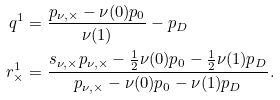<formula> <loc_0><loc_0><loc_500><loc_500>q ^ { 1 } & = \frac { p _ { \nu , \times } - \nu ( 0 ) p _ { 0 } } { \nu ( 1 ) } - p _ { D } \\ r ^ { 1 } _ { \times } & = \frac { s _ { \nu , \times } p _ { \nu , \times } - \frac { 1 } { 2 } \nu ( 0 ) p _ { 0 } - \frac { 1 } { 2 } \nu ( 1 ) p _ { D } } { p _ { \nu , \times } - \nu ( 0 ) p _ { 0 } - \nu ( 1 ) p _ { D } } .</formula> 